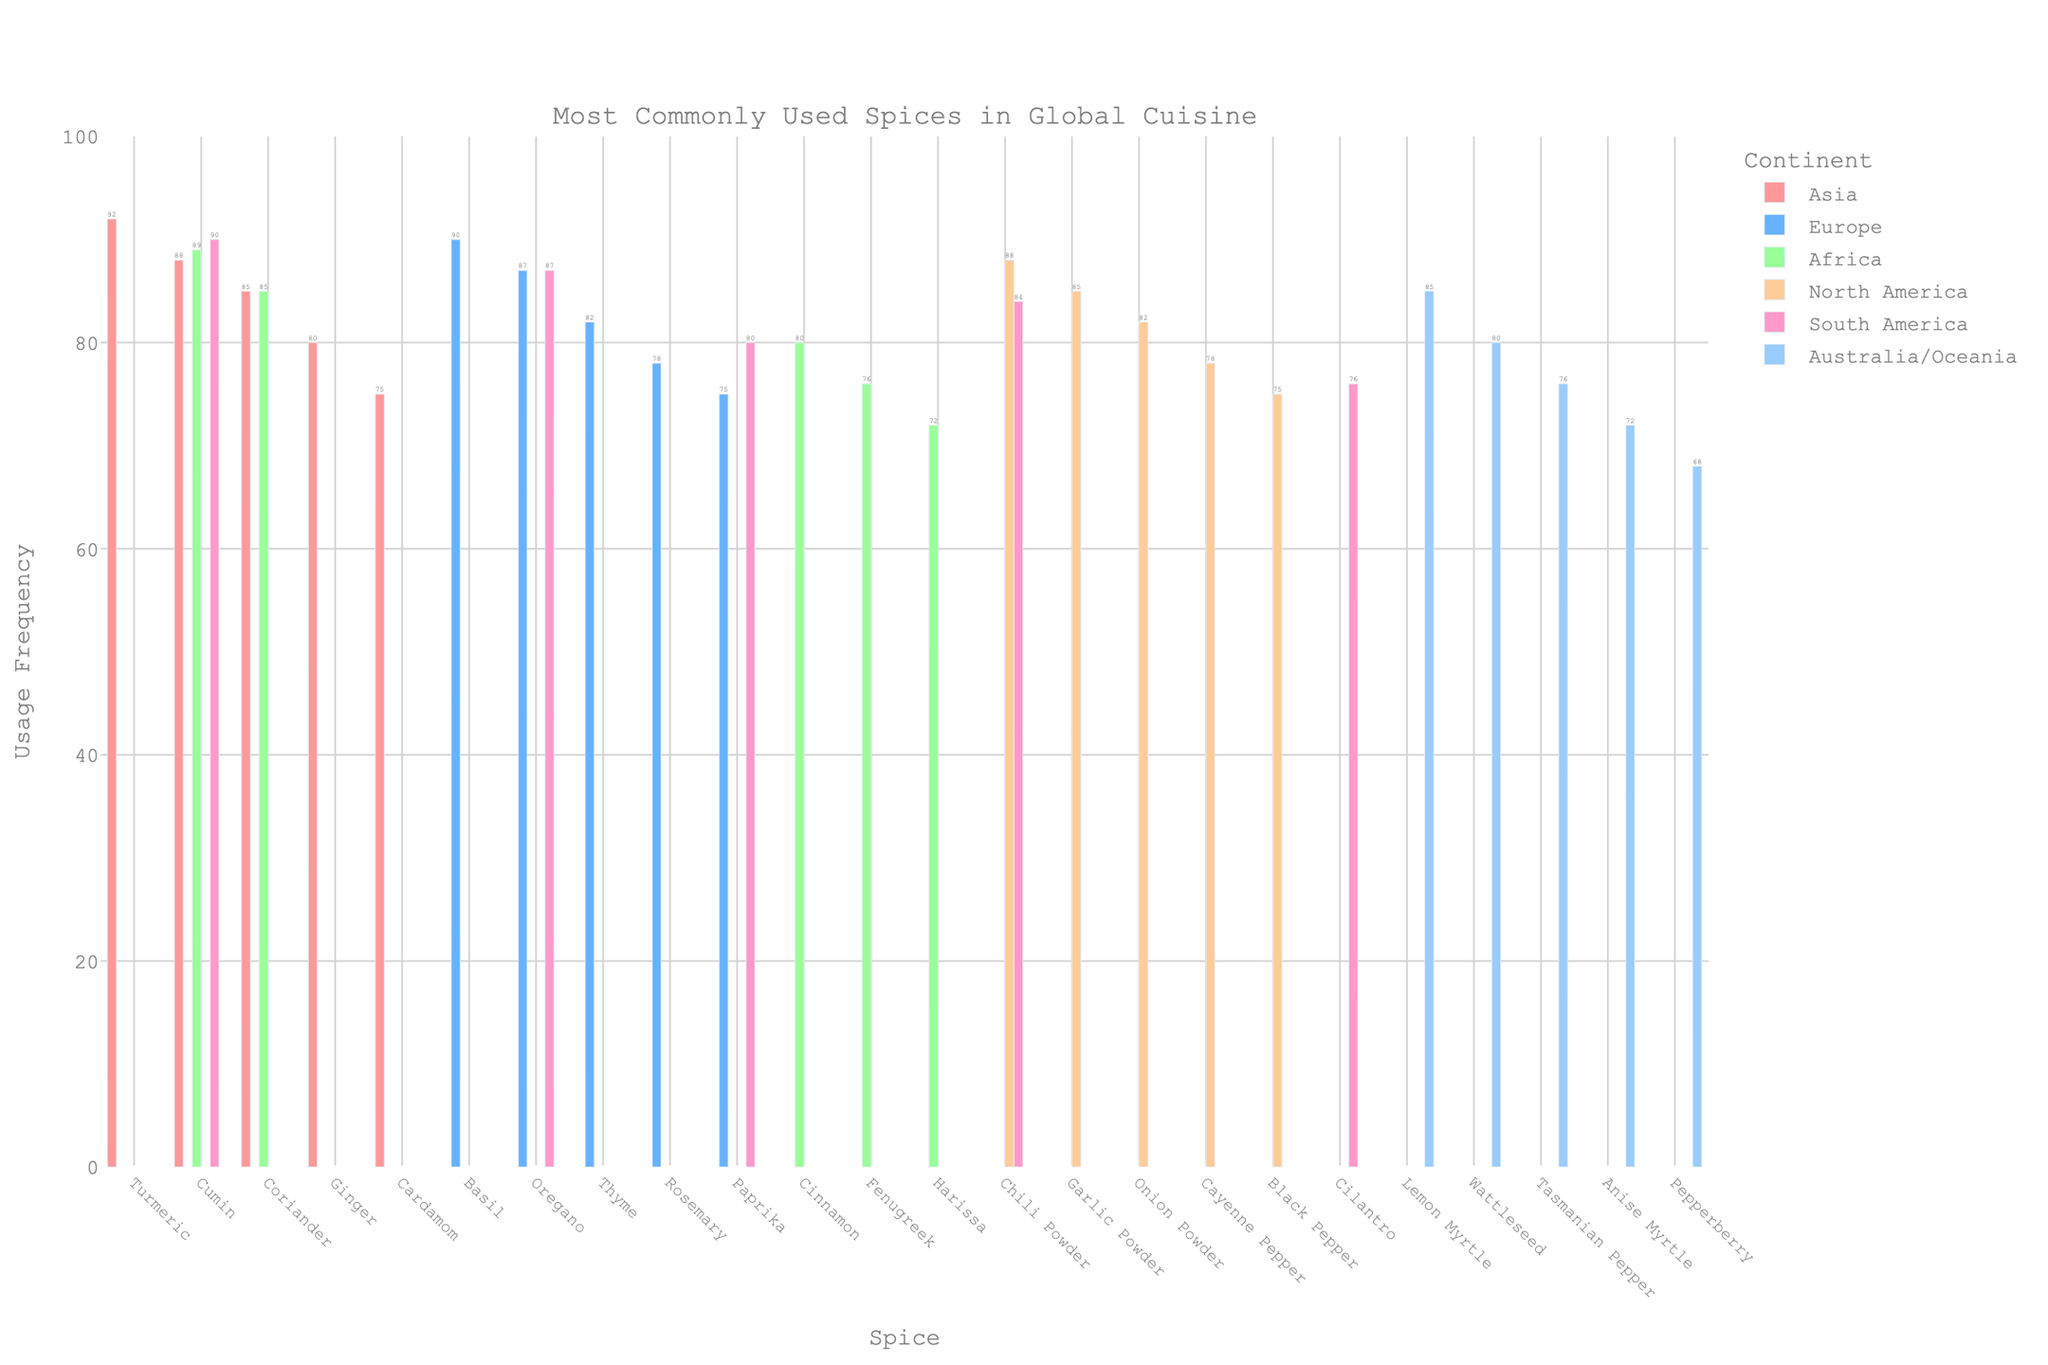Which continent uses Oregano the most? Refer to the bar heights for Oregano. Europe has the highest bar for Oregano with a usage frequency of 87, while South America's is also 87. Therefore, both Europe and South America use it equally the most.
Answer: Europe and South America Which spice has the highest usage frequency in Asia? Check the bar heights within the Asia category. Turmeric has the highest bar with a usage frequency of 92.
Answer: Turmeric Which continent has the least commonly used spice, and what is that spice? Identify the shortest bar across all continents. The Pepperberry bar in Australia/Oceania is the shortest with a frequency of 68.
Answer: Australia/Oceania, Pepperberry What is the usage frequency difference between Chili Powder in North America and South America? Look at the bar heights for Chili Powder. North America has 88 and South America has 84. The difference is \( 88 - 84 = 4 \).
Answer: 4 Which continent has the most diverse types of spices listed? Count the number of bars per continent. Asia and Europe have five spices each. Both have the most diverse types of spices listed.
Answer: Asia and Europe Compare the average usage frequency of spices between Africa and Australia/Oceania. Which one is higher and by how much? Calculate the average for both continents. Africa: \( (89 + 85 + 80 + 76 + 72) / 5 = 80.4 \). Australia/Oceania: \( (85 + 80 + 76 + 72 + 68) / 5 = 76.2 \). The difference is \( 80.4 - 76.2 = 4.2 \), so Africa is higher.
Answer: Africa, 4.2 Which spice appears across the most continents, and on how many continents does it appear? Identify spices that are listed under different continents. Cumin appears in Asia, Africa, and South America. Thus, it appears on 3 continents.
Answer: Cumin, 3 Which continent has the highest overall sum of usage frequencies across its spices? Calculate the sum of usage frequencies for each continent. Europe: \( 90 + 87 + 82 + 78 + 75 = 412 \). Asia: \( 92 + 88 + 85 + 80 + 75 = 420 \). Africa: \( 89 + 85 + 80 + 76 + 72 = 402 \). North America: \( 88 + 85 + 82 + 78 + 75 = 408 \). South America: \( 90 + 87 + 84 + 80 + 76 = 417 \). Australia/Oceania: \( 85 + 80 + 76 + 72 + 68 = 381 \). Asia has the highest sum.
Answer: Asia What is the most common usage frequency among all the spices in the chart? Check for the frequency that appears most often. Both usages of 85 appear four times (Coriander in Asia and Africa, Garlic Powder in North America, and Lemon Myrtle in Australia/Oceania).
Answer: 85 